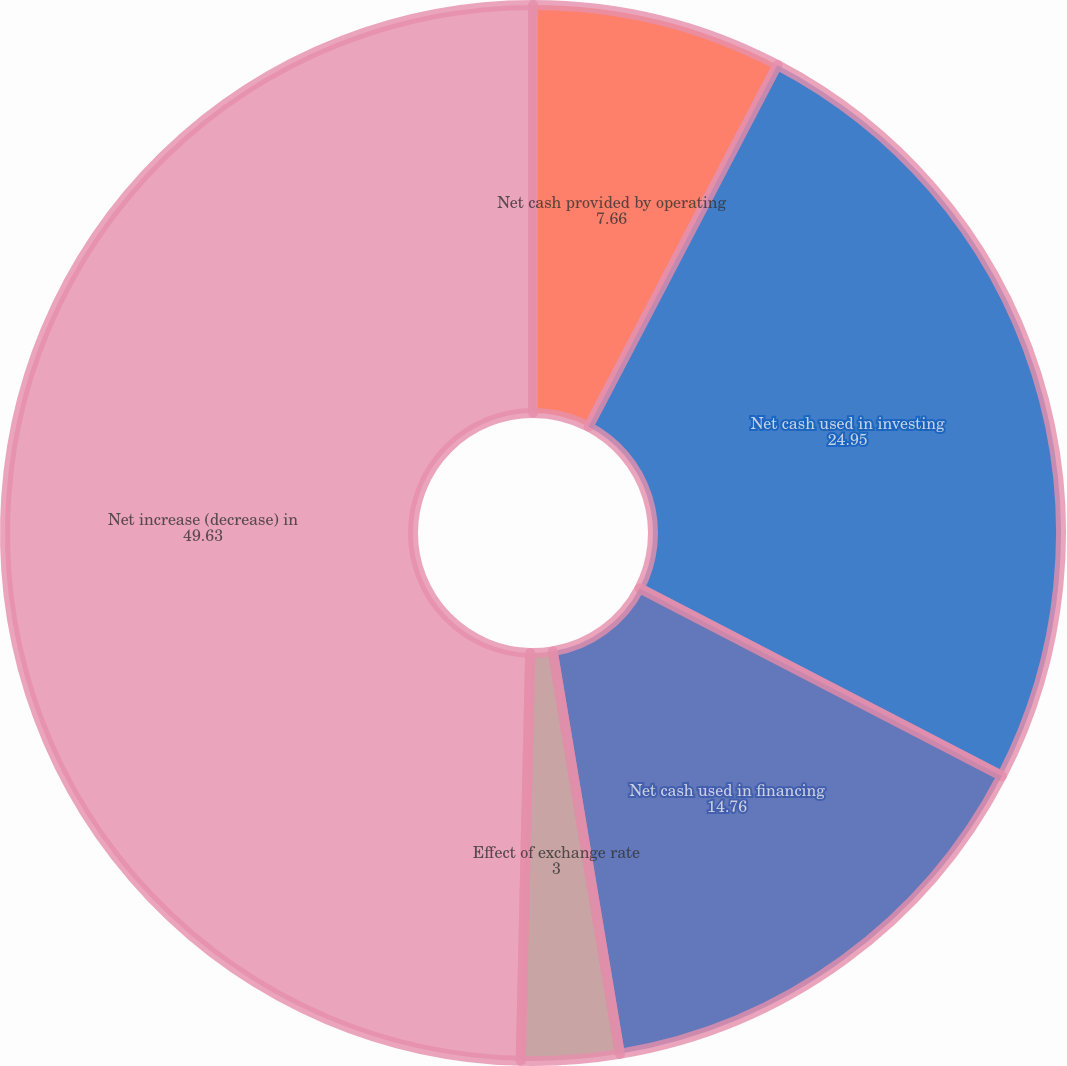<chart> <loc_0><loc_0><loc_500><loc_500><pie_chart><fcel>Net cash provided by operating<fcel>Net cash used in investing<fcel>Net cash used in financing<fcel>Effect of exchange rate<fcel>Net increase (decrease) in<nl><fcel>7.66%<fcel>24.95%<fcel>14.76%<fcel>3.0%<fcel>49.63%<nl></chart> 